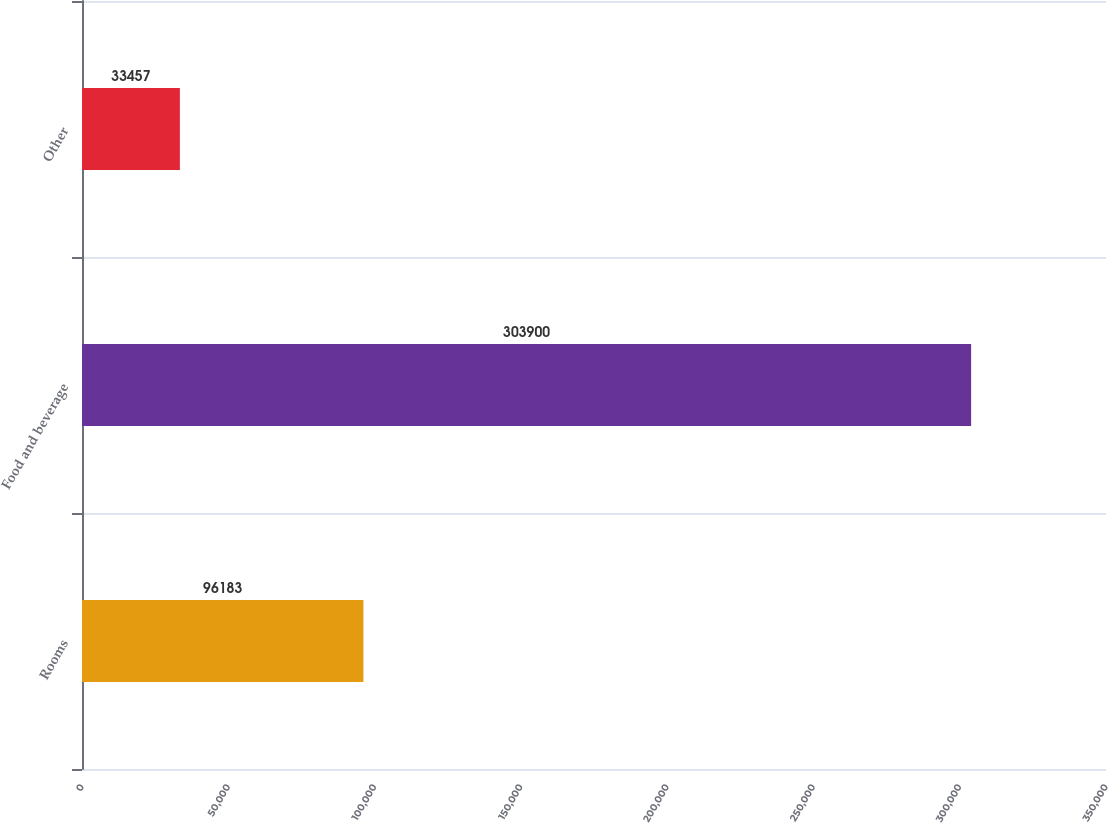<chart> <loc_0><loc_0><loc_500><loc_500><bar_chart><fcel>Rooms<fcel>Food and beverage<fcel>Other<nl><fcel>96183<fcel>303900<fcel>33457<nl></chart> 